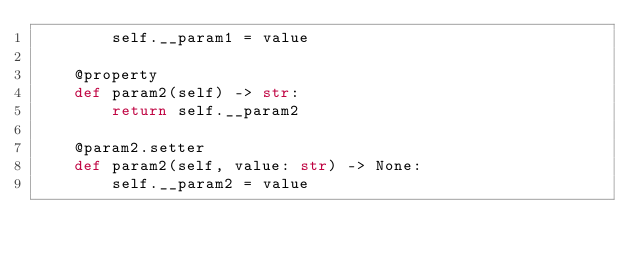Convert code to text. <code><loc_0><loc_0><loc_500><loc_500><_Python_>        self.__param1 = value
    
    @property
    def param2(self) -> str:
        return self.__param2
    
    @param2.setter
    def param2(self, value: str) -> None:
        self.__param2 = value
</code> 